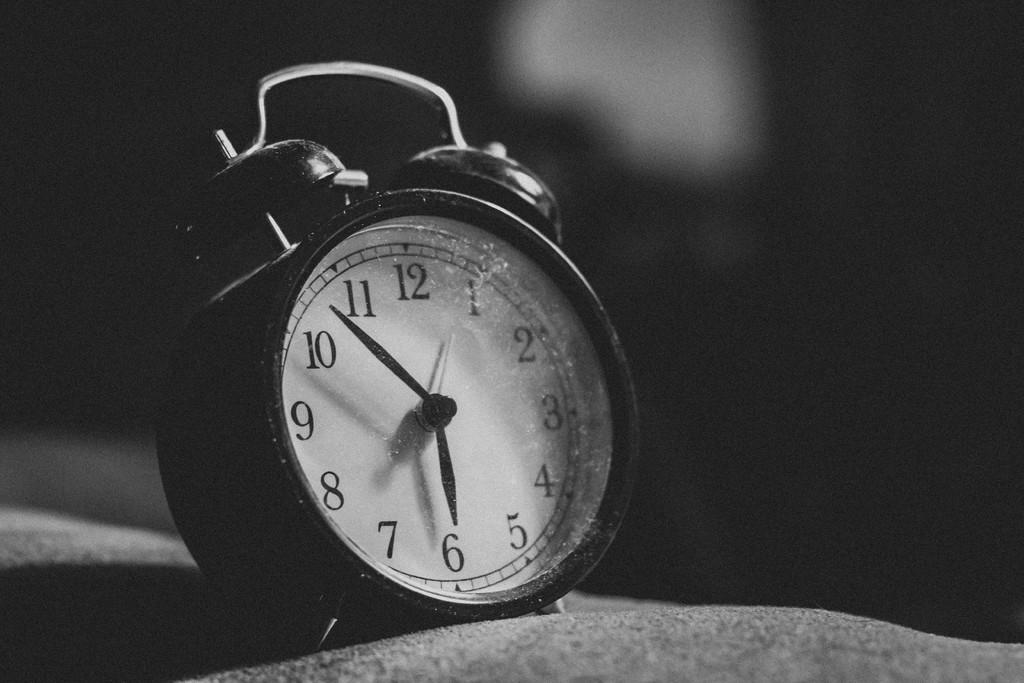<image>
Offer a succinct explanation of the picture presented. An old fashioned alarm clock with bells on top shows the time as 5:52. 